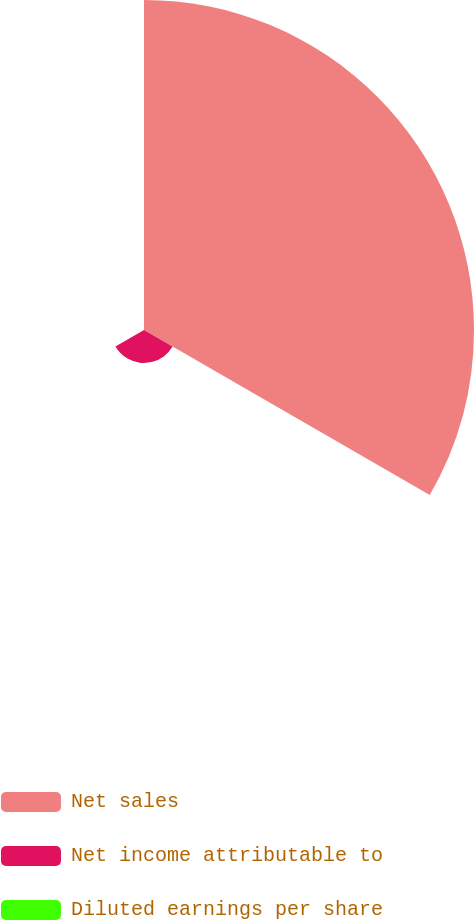Convert chart to OTSL. <chart><loc_0><loc_0><loc_500><loc_500><pie_chart><fcel>Net sales<fcel>Net income attributable to<fcel>Diluted earnings per share<nl><fcel>90.91%<fcel>9.09%<fcel>0.0%<nl></chart> 